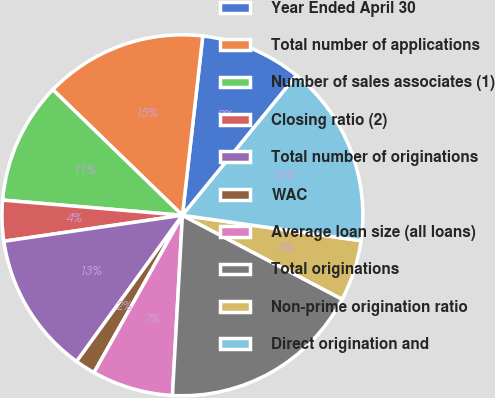Convert chart. <chart><loc_0><loc_0><loc_500><loc_500><pie_chart><fcel>Year Ended April 30<fcel>Total number of applications<fcel>Number of sales associates (1)<fcel>Closing ratio (2)<fcel>Total number of originations<fcel>WAC<fcel>Average loan size (all loans)<fcel>Total originations<fcel>Non-prime origination ratio<fcel>Direct origination and<nl><fcel>9.09%<fcel>14.55%<fcel>10.91%<fcel>3.64%<fcel>12.73%<fcel>1.82%<fcel>7.27%<fcel>18.18%<fcel>5.45%<fcel>16.36%<nl></chart> 